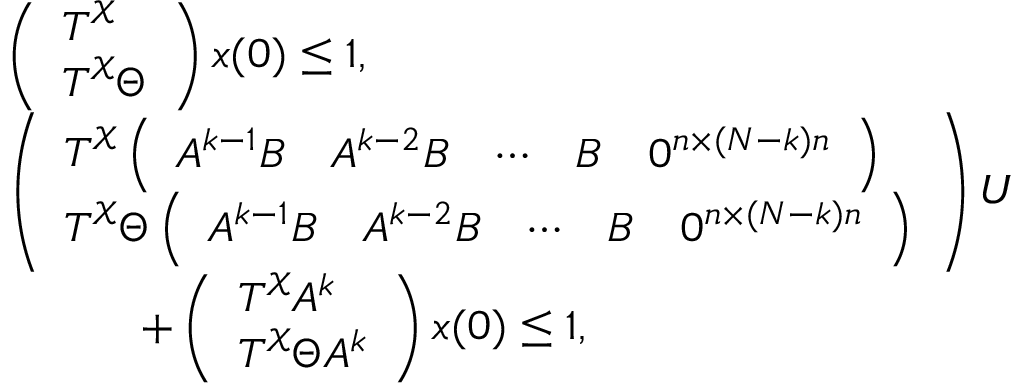<formula> <loc_0><loc_0><loc_500><loc_500>\begin{array} { r l } & { \left ( \begin{array} { l } { T ^ { \mathcal { X } } } \\ { T ^ { \mathcal { X } } \Theta } \end{array} \right ) x ( 0 ) \leq 1 , } \\ & { \left ( \begin{array} { l } { T ^ { \mathcal { X } } \left ( \begin{array} { l l l l l } { A ^ { k - 1 } B } & { A ^ { k - 2 } B } & { \cdots } & { B } & { 0 ^ { n \times ( N - k ) n } } \end{array} \right ) } \\ { T ^ { \mathcal { X } } \Theta \left ( \begin{array} { l l l l l } { A ^ { k - 1 } B } & { A ^ { k - 2 } B } & { \cdots } & { B } & { 0 ^ { n \times ( N - k ) n } } \end{array} \right ) } \end{array} \right ) U } \\ & { \quad + \left ( \begin{array} { l } { T ^ { \mathcal { X } } A ^ { k } } \\ { T ^ { \mathcal { X } } \Theta A ^ { k } } \end{array} \right ) x ( 0 ) \leq 1 , } \end{array}</formula> 